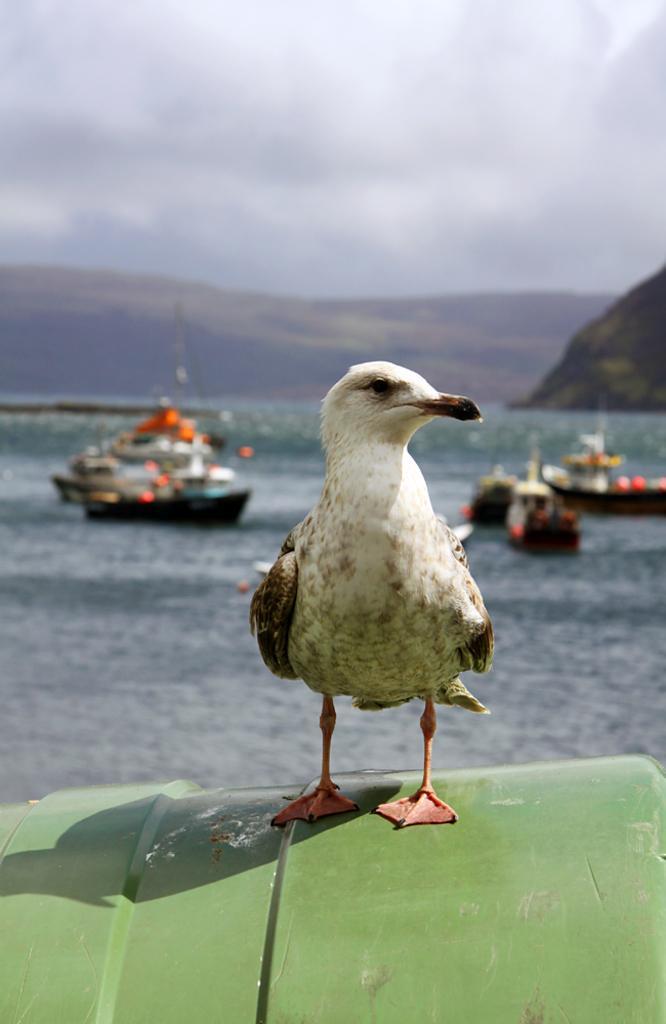How would you summarize this image in a sentence or two? In the middle of the image, there is a bird on a green color object. In the background, there are boats on the water of an ocean, there are mountains and there are clouds in the sky. 